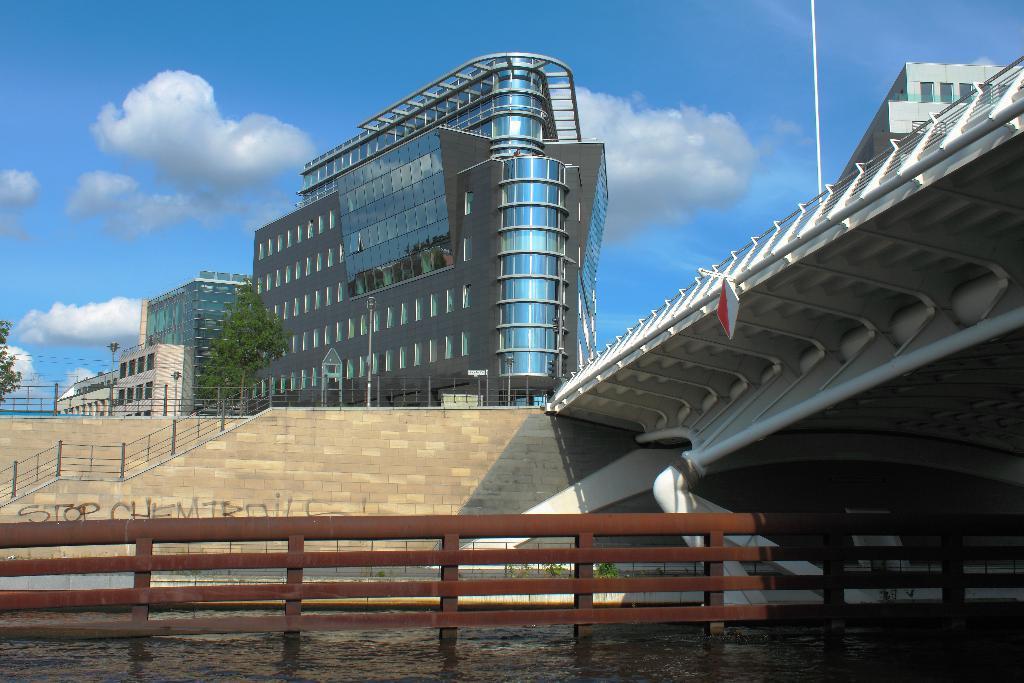Could you give a brief overview of what you see in this image? In this image, we can see buildings, trees, poles, boards, stairs, railings and we can see a bridge and there is some text on the wall. At the bottom, there is water and at the top, there are clouds in the sky. 